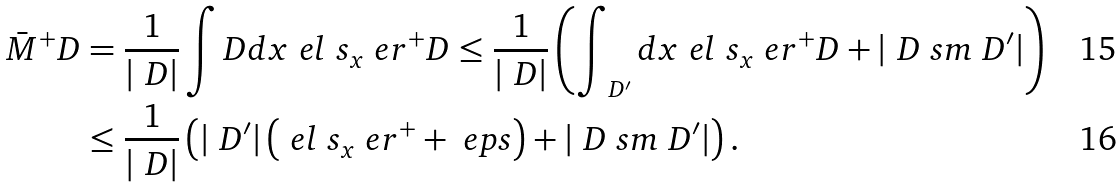<formula> <loc_0><loc_0><loc_500><loc_500>\bar { M } ^ { + } _ { \ } D & = \frac { 1 } { | \ D | } \int _ { \ } D d x \ e l \ s _ { x } \ e r ^ { + } _ { \ } D \leq \frac { 1 } { | \ D | } \left ( \int _ { \ D ^ { \prime } } d x \ e l \ s _ { x } \ e r ^ { + } _ { \ } D + | \ D \ s m \ D ^ { \prime } | \right ) \\ & \leq \frac { 1 } { | \ D | } \left ( | \ D ^ { \prime } | \left ( \ e l \ s _ { x } \ e r ^ { + } + \ e p s \right ) + | \ D \ s m \ D ^ { \prime } | \right ) .</formula> 